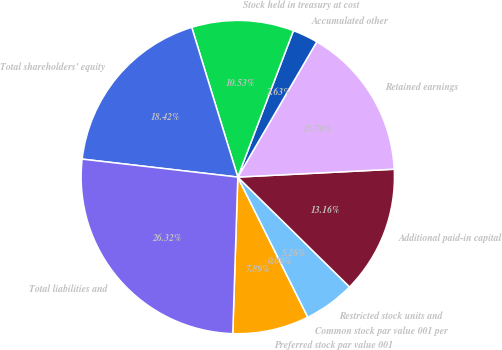<chart> <loc_0><loc_0><loc_500><loc_500><pie_chart><fcel>Preferred stock par value 001<fcel>Common stock par value 001 per<fcel>Restricted stock units and<fcel>Additional paid-in capital<fcel>Retained earnings<fcel>Accumulated other<fcel>Stock held in treasury at cost<fcel>Total shareholders' equity<fcel>Total liabilities and<nl><fcel>7.89%<fcel>0.0%<fcel>5.26%<fcel>13.16%<fcel>15.79%<fcel>2.63%<fcel>10.53%<fcel>18.42%<fcel>26.32%<nl></chart> 